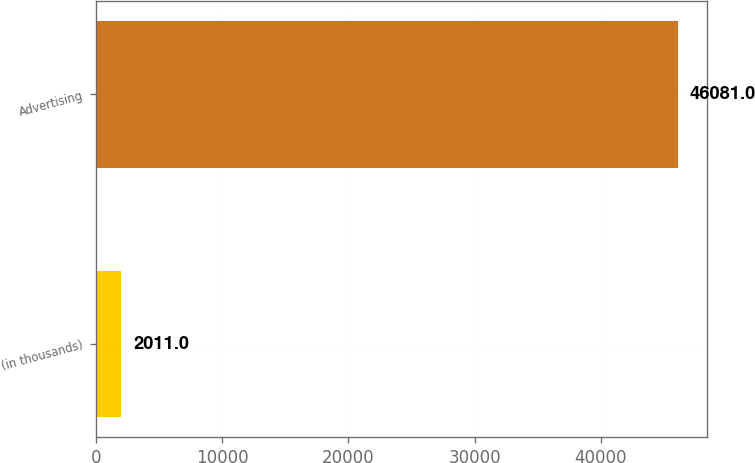Convert chart. <chart><loc_0><loc_0><loc_500><loc_500><bar_chart><fcel>(in thousands)<fcel>Advertising<nl><fcel>2011<fcel>46081<nl></chart> 